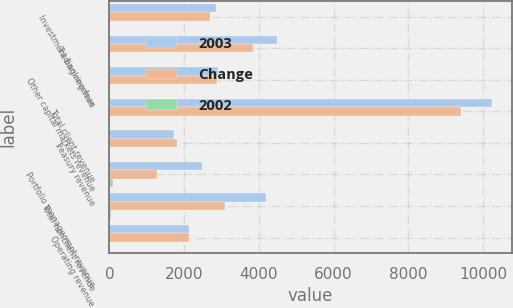<chart> <loc_0><loc_0><loc_500><loc_500><stacked_bar_chart><ecel><fcel>Investment banking fees<fcel>Trading revenue<fcel>Other capital markets revenue<fcel>Total client revenue<fcel>Treasury revenue<fcel>Portfolio management revenue<fcel>Total nonclient revenue<fcel>Operating revenue<nl><fcel>2003<fcel>2855<fcel>4485<fcel>2904<fcel>10244<fcel>1726<fcel>2470<fcel>4196<fcel>2142.5<nl><fcel>Change<fcel>2696<fcel>3840<fcel>2875<fcel>9411<fcel>1815<fcel>1272<fcel>3087<fcel>2142.5<nl><fcel>2002<fcel>6<fcel>17<fcel>1<fcel>9<fcel>5<fcel>94<fcel>36<fcel>16<nl></chart> 